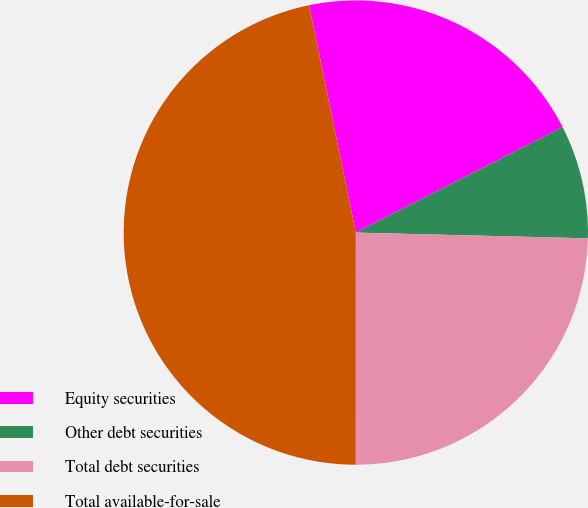<chart> <loc_0><loc_0><loc_500><loc_500><pie_chart><fcel>Equity securities<fcel>Other debt securities<fcel>Total debt securities<fcel>Total available-for-sale<nl><fcel>20.72%<fcel>7.9%<fcel>24.61%<fcel>46.76%<nl></chart> 